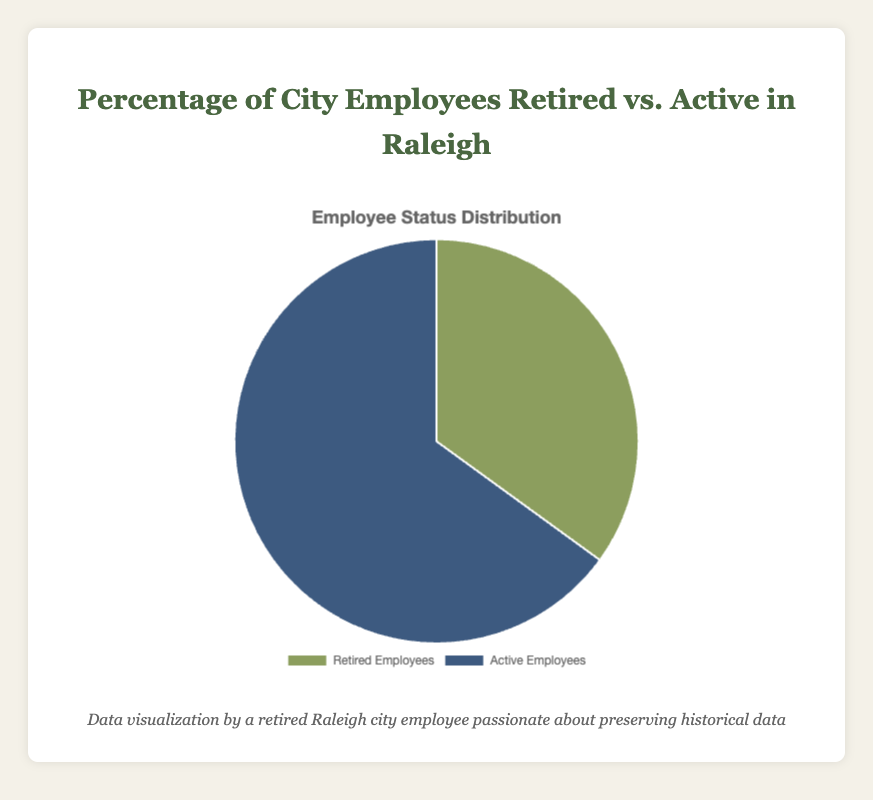What percentage of Raleigh city employees is retired? The pie chart shows two categories: Retired Employees and Active Employees. The Retired Employees portion is 35%.
Answer: 35% Which group has the higher percentage, retired or active city employees? The pie chart shows that Active Employees have a larger section compared to Retired Employees. The percentages are 65% for Active Employees and 35% for Retired Employees.
Answer: Active Employees What is the difference in percentage between active and retired city employees? To find the difference, subtract the smaller percentage (Retired Employees) from the larger percentage (Active Employees): 65% - 35% = 30%.
Answer: 30% What visual colors represent the retired and active employee categories? The pie chart uses different colors for different categories. Retired Employees are represented in green, while Active Employees are represented in blue.
Answer: Green for Retired Employees, Blue for Active Employees If the total number of city employees is 10,000, how many of them are retired? Given 35% are retired, calculate 35% of 10,000: 0.35 × 10,000 = 3,500.
Answer: 3,500 If the total number of city employees is 10,000, how many are active employees? Given 65% are active, calculate 65% of 10,000: 0.65 × 10,000 = 6,500.
Answer: 6,500 What is the ratio of active to retired employees? Divide the percentage of active employees by the percentage of retired employees: 65% / 35% = 65/35 = 13/7.
Answer: 13:7 What is the combined percentage of retired and active employees together? Add the two percentages together: 35% + 65% = 100%.
Answer: 100% Which employee status is represented with a larger segment area on the pie chart? The pie chart shows that Active Employees have a larger segment area compared to Retired Employees.
Answer: Active Employees 